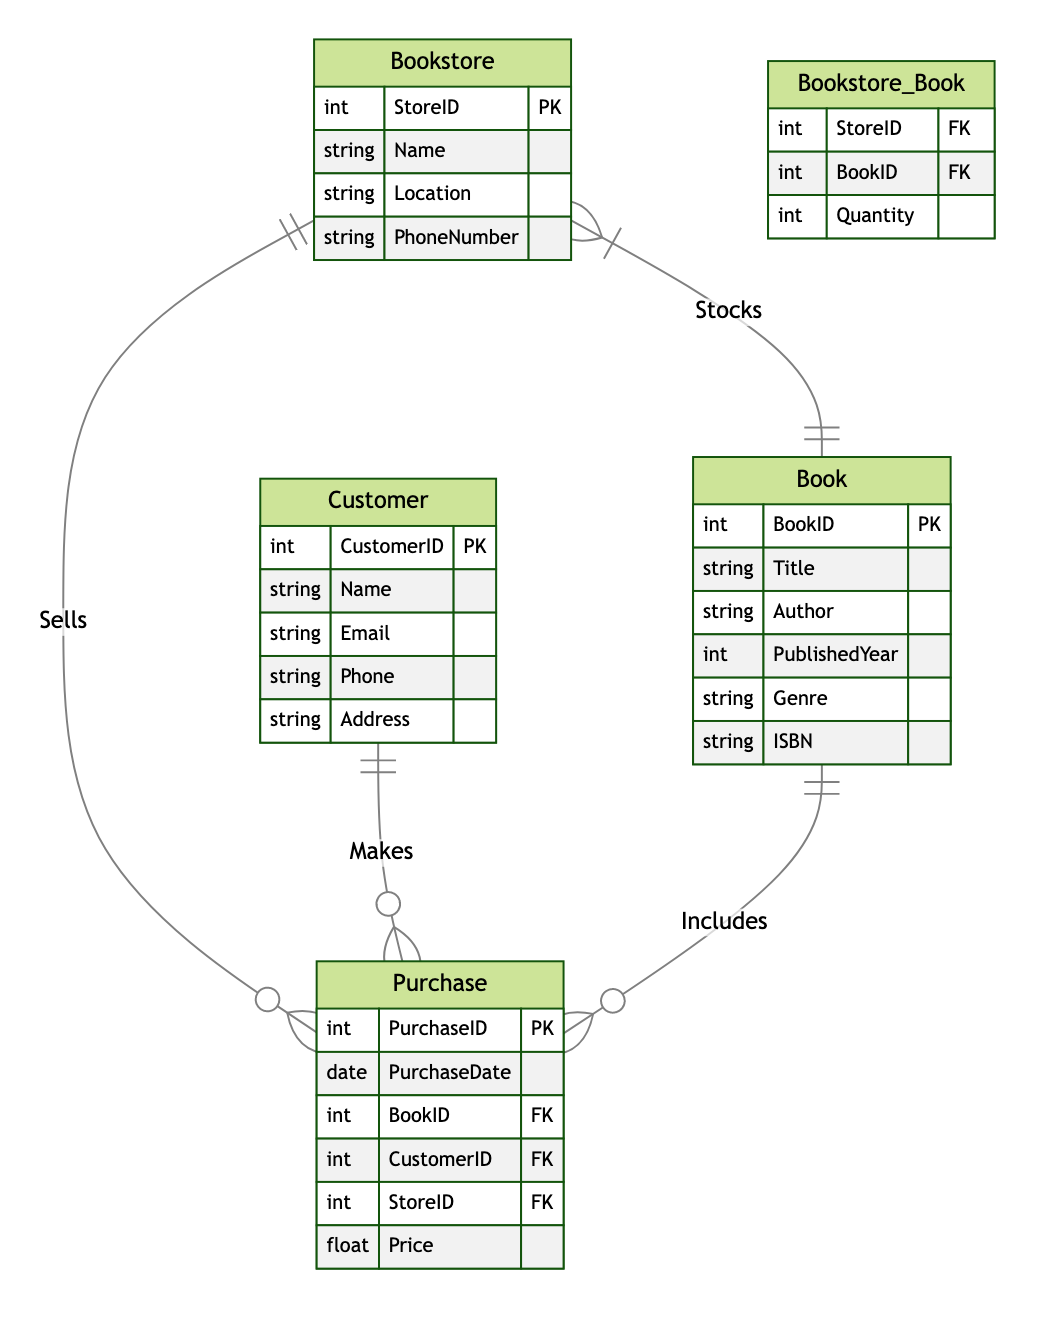What is the primary key of the Bookstore entity? The primary key of the Bookstore entity is StoreID, which uniquely identifies each bookstore in the database.
Answer: StoreID How many attributes does the Book entity have? The Book entity has six attributes: BookID, Title, Author, PublishedYear, Genre, and ISBN.
Answer: Six Which relationship does the Customer entity participate in? The Customer entity participates in the Makes relationship, indicating that one customer can make many purchases.
Answer: Makes What type of relationship exists between Bookstore and Book? The relationship between Bookstore and Book is Many-to-Many, indicating that a bookstore can stock multiple books, and a book can be available in multiple bookstores.
Answer: Many-to-Many How many foreign keys are present in the Purchase entity? The Purchase entity has three foreign keys: BookID, CustomerID, and StoreID, which link to the Book, Customer, and Bookstore entities respectively.
Answer: Three What is the quantity of books in the Stocks relationship represented as? The quantity of books in the Stocks relationship is represented as an attribute called Quantity, which specifies how many copies of each book are available at each bookstore.
Answer: Quantity Which entity can have multiple purchases made by a customer? The Customer entity can have multiple purchases made, as represented by the One-to-Many relationship between Customer and Purchase.
Answer: Customer How many unique entities are defined in this diagram? There are four unique entities defined in this diagram: Bookstore, Book, Customer, and Purchase.
Answer: Four Which entity directly links to the Sells relationship? The Bookstore entity directly links to the Sells relationship, indicating that bookstores sell purchases made by customers.
Answer: Bookstore 